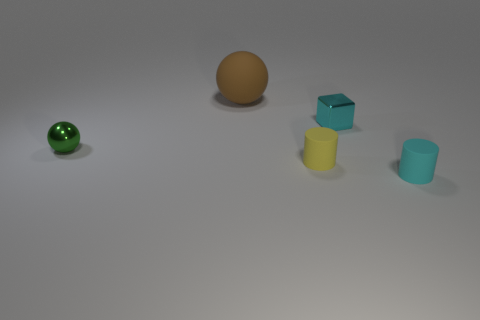Add 5 brown objects. How many objects exist? 10 Subtract all balls. How many objects are left? 3 Subtract all tiny yellow matte balls. Subtract all tiny yellow matte cylinders. How many objects are left? 4 Add 2 tiny green metal objects. How many tiny green metal objects are left? 3 Add 5 big gray shiny things. How many big gray shiny things exist? 5 Subtract 0 purple spheres. How many objects are left? 5 